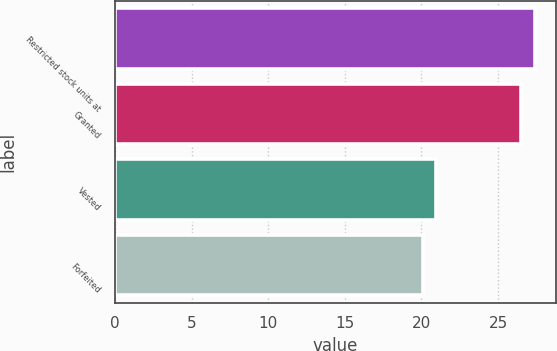Convert chart to OTSL. <chart><loc_0><loc_0><loc_500><loc_500><bar_chart><fcel>Restricted stock units at<fcel>Granted<fcel>Vested<fcel>Forfeited<nl><fcel>27.39<fcel>26.48<fcel>20.96<fcel>20.13<nl></chart> 